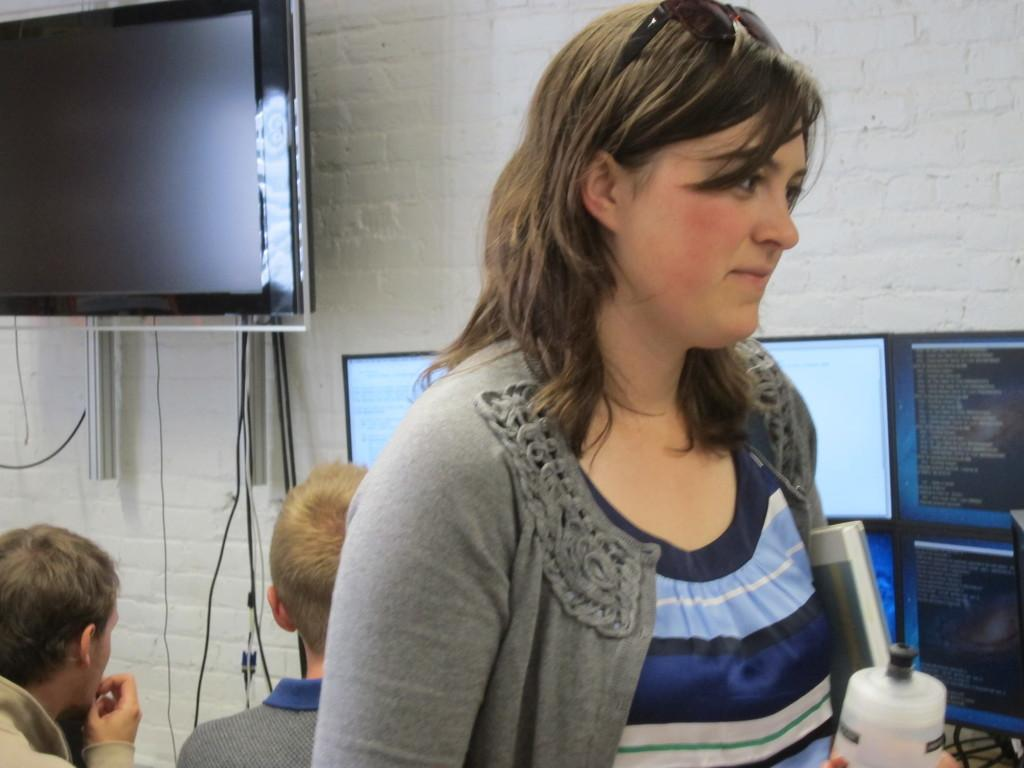What is the woman in the image holding? The woman is holding a bottle and a book. Can you describe the people visible behind the woman? There are people visible behind the woman, but their specific actions or features cannot be determined from the provided facts. What is on the wall in the image? There is a television on the wall. What type of cables can be seen in the image? There are cables in the image, but their specific purpose or function cannot be determined from the provided facts. What might the screens be used for in the image? The presence of screens suggests that they might be used for displaying information or media, but their specific content cannot be determined from the provided facts. What type of star is visible in the image? There is no star visible in the image; it is an indoor scene with a woman, a bottle, a book, people, a television, cables, and screens. 